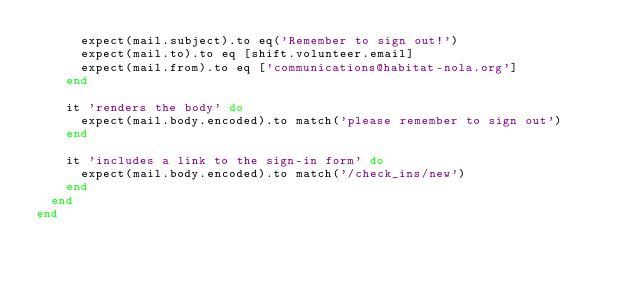<code> <loc_0><loc_0><loc_500><loc_500><_Ruby_>      expect(mail.subject).to eq('Remember to sign out!')
      expect(mail.to).to eq [shift.volunteer.email]
      expect(mail.from).to eq ['communications@habitat-nola.org']
    end

    it 'renders the body' do
      expect(mail.body.encoded).to match('please remember to sign out')
    end

    it 'includes a link to the sign-in form' do
      expect(mail.body.encoded).to match('/check_ins/new')
    end
  end
end
</code> 